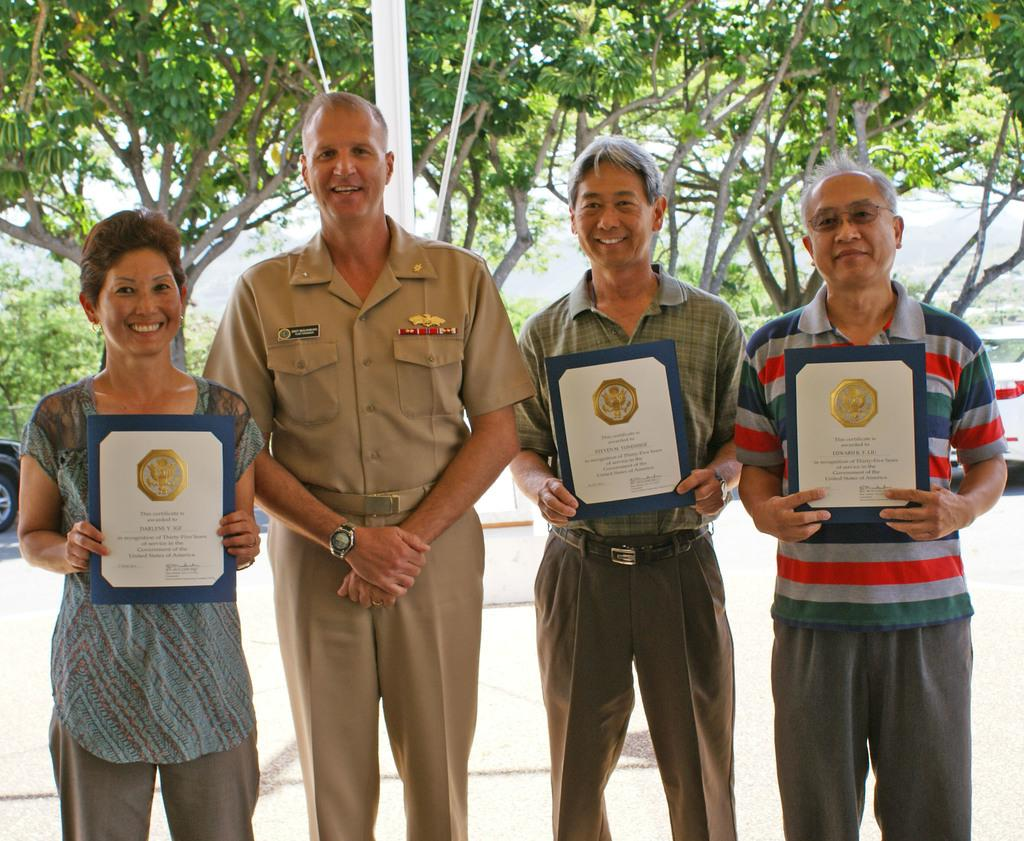How many people are present in the image? There are four people in the image. What are the people doing in the image? The people are standing on the ground and smiling. What are three of the people holding? Three people are holding momentous in the image. What can be seen in the background of the image? There are vehicles, trees, a pole, and ropes in the background. What type of picture is hanging on the pole in the background? There is no picture hanging on the pole in the background; the pole is a separate element in the image. Can you tell me how many hens are present in the image? There are no hens present in the image. Who is the representative of the group in the image? The image does not indicate a specific representative for the group. 